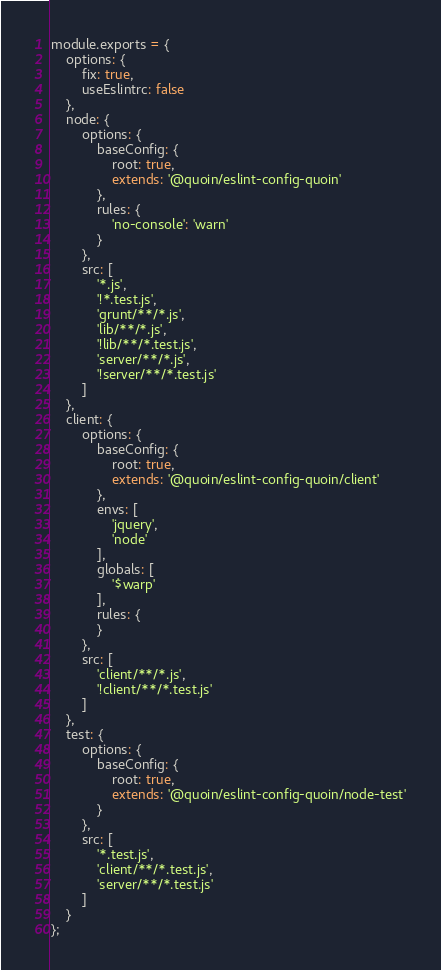<code> <loc_0><loc_0><loc_500><loc_500><_JavaScript_>module.exports = {
    options: {
        fix: true,
        useEslintrc: false
    },
    node: {
        options: {
            baseConfig: {
                root: true,
                extends: '@quoin/eslint-config-quoin'
            },
            rules: {
                'no-console': 'warn'
            }
        },
        src: [
            '*.js',
            '!*.test.js',
            'grunt/**/*.js',
            'lib/**/*.js',
            '!lib/**/*.test.js',
            'server/**/*.js',
            '!server/**/*.test.js'
        ]
    },
    client: {
        options: {
            baseConfig: {
                root: true,
                extends: '@quoin/eslint-config-quoin/client'
            },
            envs: [
                'jquery',
                'node'
            ],
            globals: [
                '$warp'
            ],
            rules: {
            }
        },
        src: [
            'client/**/*.js',
            '!client/**/*.test.js'
        ]
    },
    test: {
        options: {
            baseConfig: {
                root: true,
                extends: '@quoin/eslint-config-quoin/node-test'
            }
        },
        src: [
            '*.test.js',
            'client/**/*.test.js',
            'server/**/*.test.js'
        ]
    }
};
</code> 